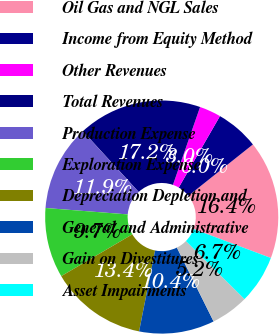Convert chart to OTSL. <chart><loc_0><loc_0><loc_500><loc_500><pie_chart><fcel>Oil Gas and NGL Sales<fcel>Income from Equity Method<fcel>Other Revenues<fcel>Total Revenues<fcel>Production Expense<fcel>Exploration Expense<fcel>Depreciation Depletion and<fcel>General and Administrative<fcel>Gain on Divestitures<fcel>Asset Impairments<nl><fcel>16.41%<fcel>5.97%<fcel>2.99%<fcel>17.16%<fcel>11.94%<fcel>9.7%<fcel>13.43%<fcel>10.45%<fcel>5.23%<fcel>6.72%<nl></chart> 